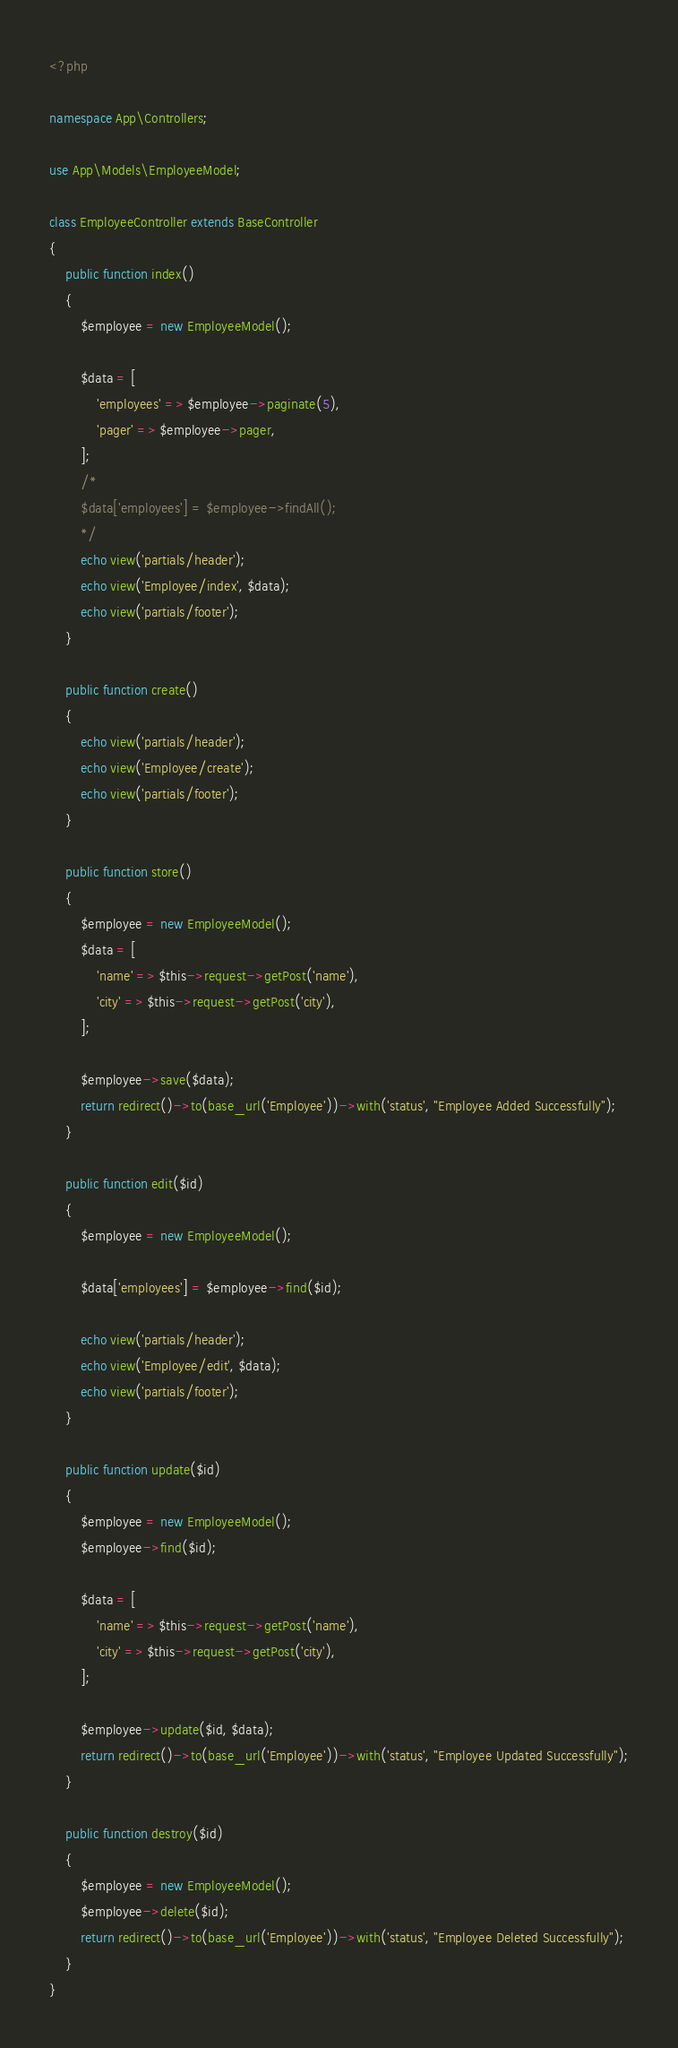Convert code to text. <code><loc_0><loc_0><loc_500><loc_500><_PHP_><?php

namespace App\Controllers;

use App\Models\EmployeeModel;

class EmployeeController extends BaseController
{
    public function index()
    {
    	$employee = new EmployeeModel();

    	$data = [
    		'employees' => $employee->paginate(5),
    		'pager' => $employee->pager,
    	];
    	/*
    	$data['employees'] = $employee->findAll();
		*/
        echo view('partials/header');
        echo view('Employee/index', $data);
        echo view('partials/footer');
    }

    public function create()
    {
        echo view('partials/header');
        echo view('Employee/create');
        echo view('partials/footer');
    }

    public function store()
    {
    	$employee = new EmployeeModel();
    	$data = [
    		'name' => $this->request->getPost('name'),
    		'city' => $this->request->getPost('city'),
    	];

    	$employee->save($data);
    	return redirect()->to(base_url('Employee'))->with('status', "Employee Added Successfully");
    }

    public function edit($id)
    {
    	$employee = new EmployeeModel();

    	$data['employees'] = $employee->find($id);

        echo view('partials/header');
        echo view('Employee/edit', $data);
        echo view('partials/footer');
    }

    public function update($id)
    {
    	$employee = new EmployeeModel();
    	$employee->find($id);

    	$data = [
    		'name' => $this->request->getPost('name'),
    		'city' => $this->request->getPost('city'),
    	];

    	$employee->update($id, $data);
    	return redirect()->to(base_url('Employee'))->with('status', "Employee Updated Successfully");
    }

    public function destroy($id)
    {
    	$employee = new EmployeeModel();
    	$employee->delete($id);
    	return redirect()->to(base_url('Employee'))->with('status', "Employee Deleted Successfully");
    }
}
</code> 